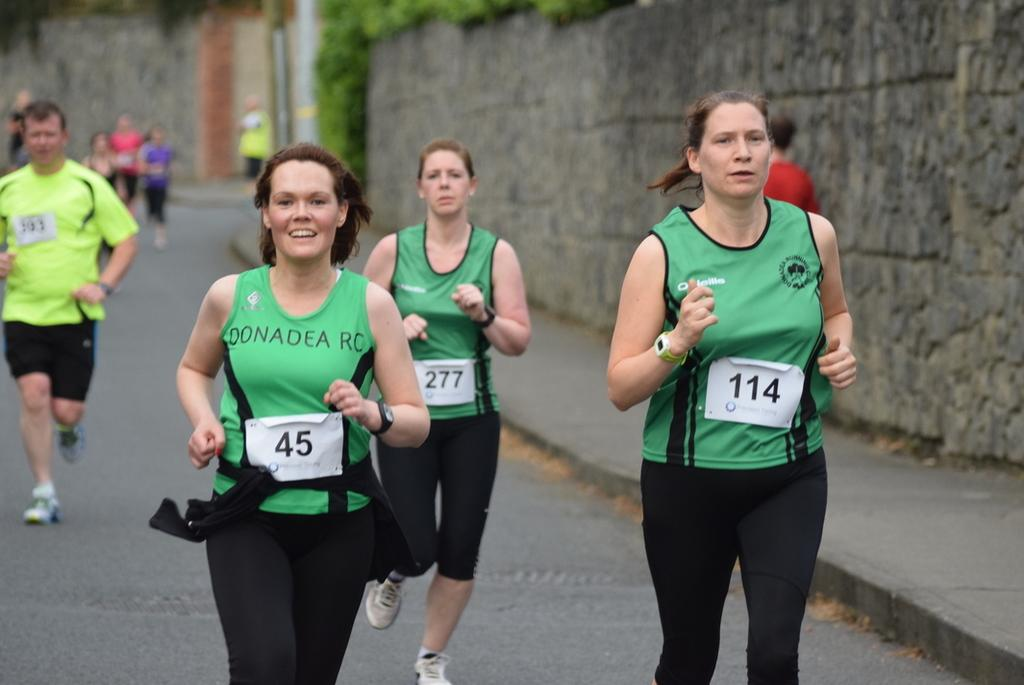<image>
Describe the image concisely. Marathoners run in the street with number 45 taking the lead. 